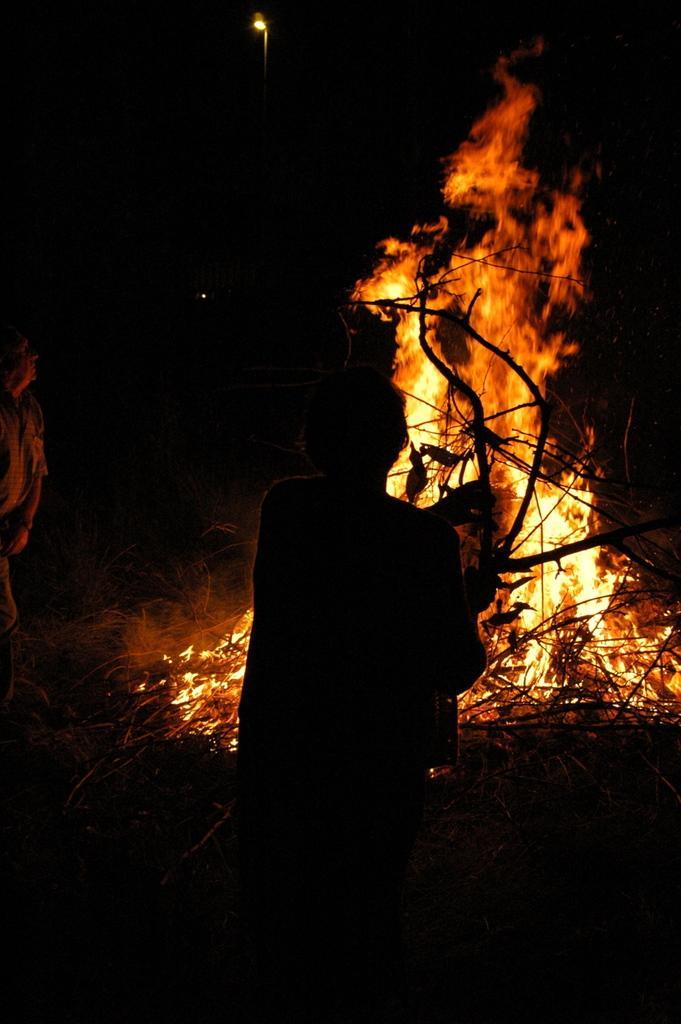In one or two sentences, can you explain what this image depicts? In this image we can see two people on the ground. We can also see some branches of a tree, fire and a light. 